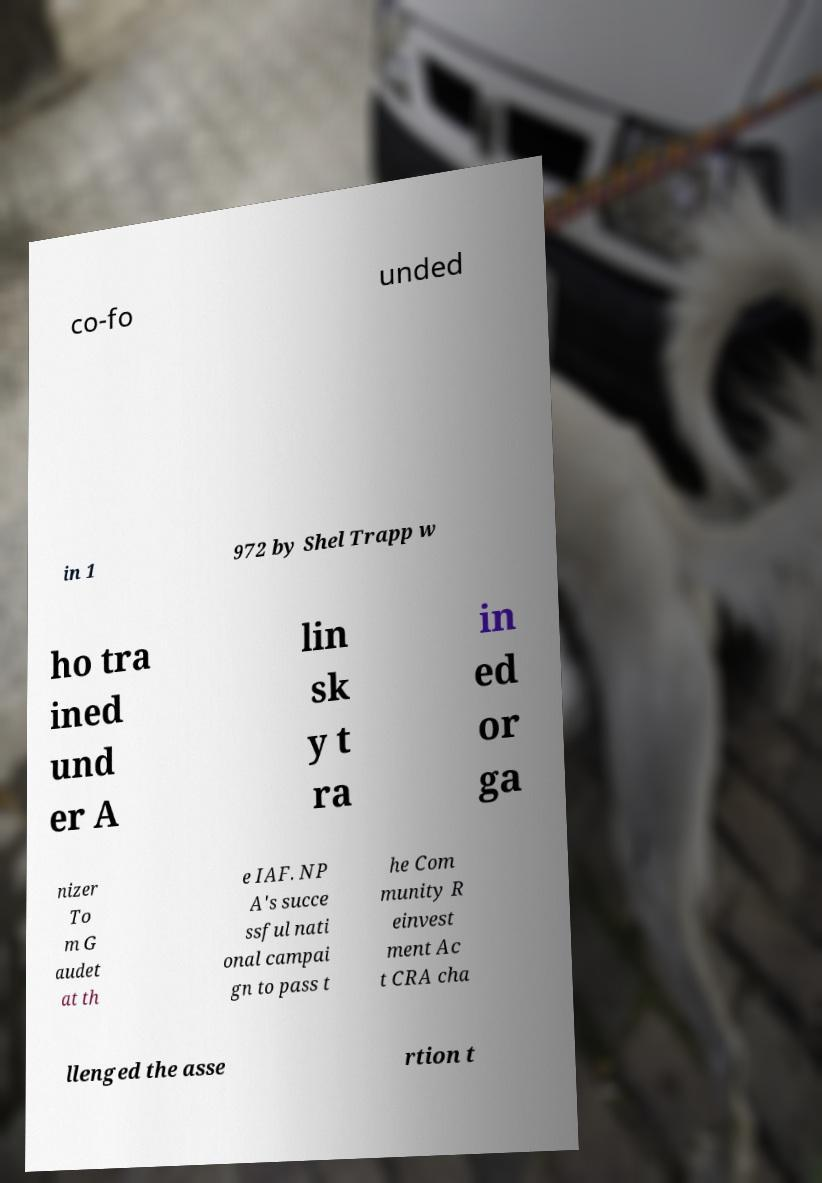Please read and relay the text visible in this image. What does it say? co-fo unded in 1 972 by Shel Trapp w ho tra ined und er A lin sk y t ra in ed or ga nizer To m G audet at th e IAF. NP A's succe ssful nati onal campai gn to pass t he Com munity R einvest ment Ac t CRA cha llenged the asse rtion t 